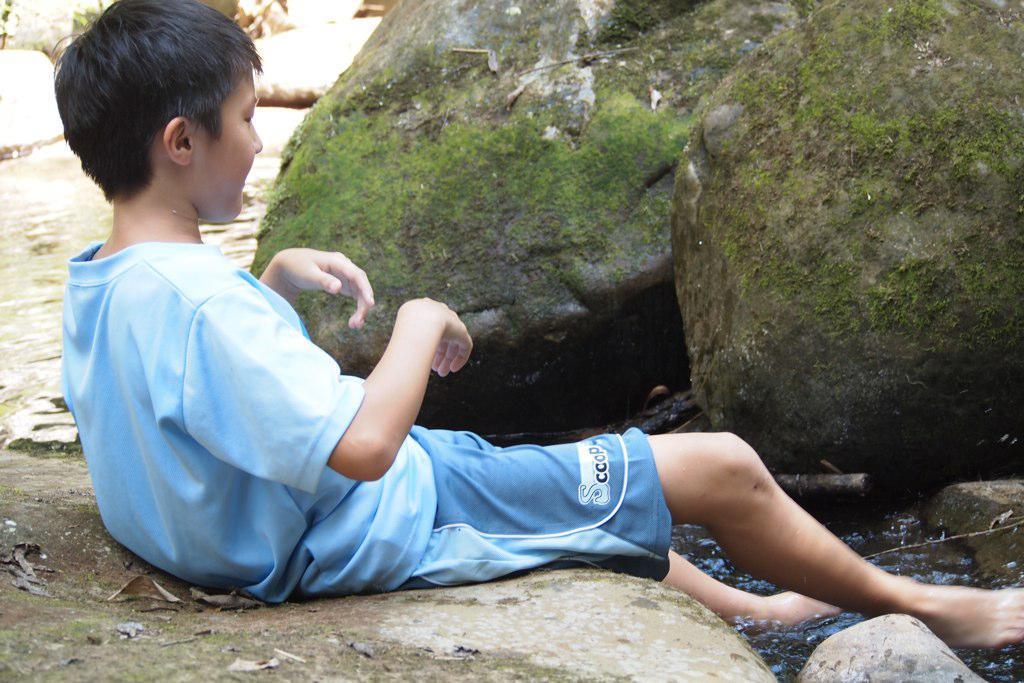How would you summarize this image in a sentence or two? In this image a boy is sitting on the floor wearing blue clothes. In the right there is water. In the background there are stones. 